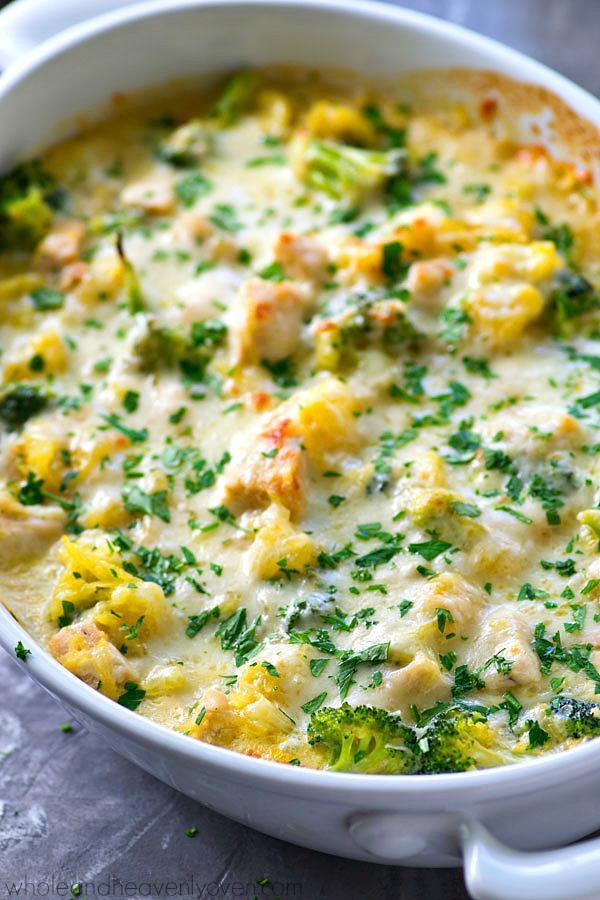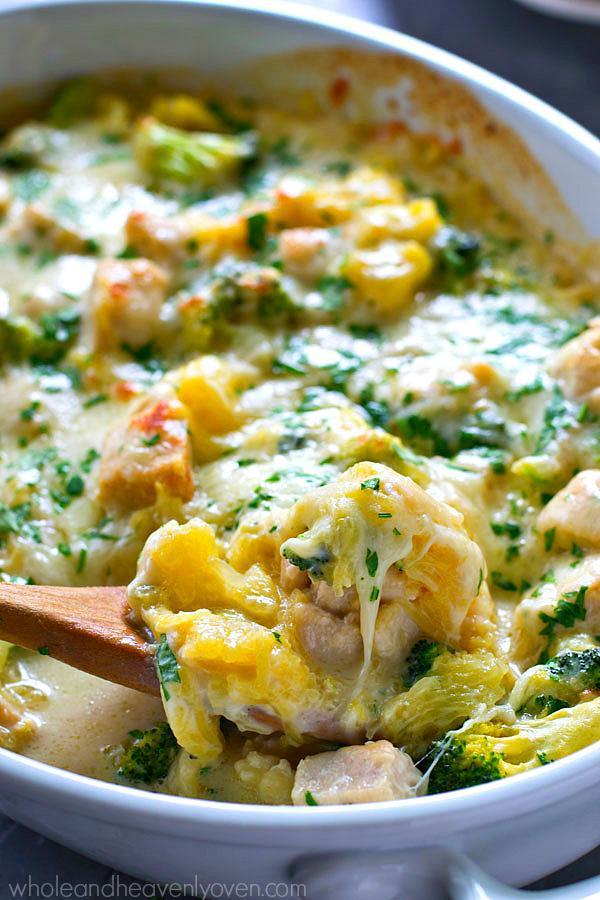The first image is the image on the left, the second image is the image on the right. Evaluate the accuracy of this statement regarding the images: "A metalic spoon is in one of the food.". Is it true? Answer yes or no. No. 